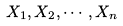<formula> <loc_0><loc_0><loc_500><loc_500>X _ { 1 } , X _ { 2 } , \cdots , X _ { n }</formula> 